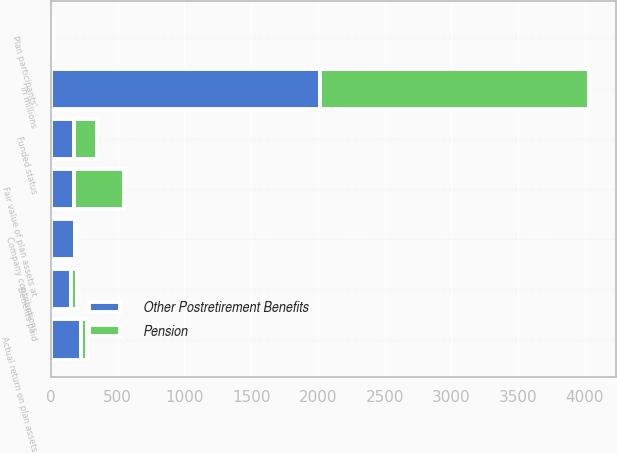Convert chart. <chart><loc_0><loc_0><loc_500><loc_500><stacked_bar_chart><ecel><fcel>In millions<fcel>Fair value of plan assets at<fcel>Actual return on plan assets<fcel>Company contributions<fcel>Plan participants'<fcel>Benefits paid<fcel>Funded status<nl><fcel>Other Postretirement Benefits<fcel>2017<fcel>173<fcel>227<fcel>178<fcel>2<fcel>152<fcel>171<nl><fcel>Pension<fcel>2017<fcel>373<fcel>45<fcel>6<fcel>12<fcel>41<fcel>173<nl></chart> 